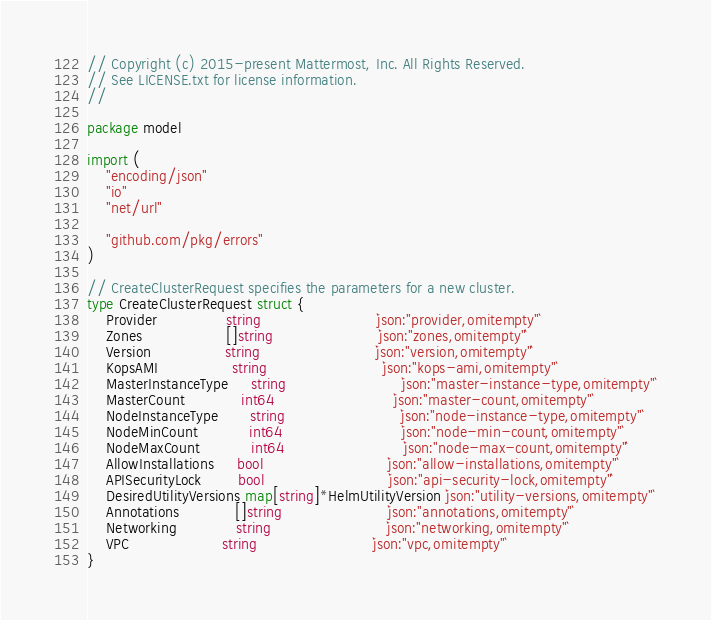Convert code to text. <code><loc_0><loc_0><loc_500><loc_500><_Go_>// Copyright (c) 2015-present Mattermost, Inc. All Rights Reserved.
// See LICENSE.txt for license information.
//

package model

import (
	"encoding/json"
	"io"
	"net/url"

	"github.com/pkg/errors"
)

// CreateClusterRequest specifies the parameters for a new cluster.
type CreateClusterRequest struct {
	Provider               string                         `json:"provider,omitempty"`
	Zones                  []string                       `json:"zones,omitempty"`
	Version                string                         `json:"version,omitempty"`
	KopsAMI                string                         `json:"kops-ami,omitempty"`
	MasterInstanceType     string                         `json:"master-instance-type,omitempty"`
	MasterCount            int64                          `json:"master-count,omitempty"`
	NodeInstanceType       string                         `json:"node-instance-type,omitempty"`
	NodeMinCount           int64                          `json:"node-min-count,omitempty"`
	NodeMaxCount           int64                          `json:"node-max-count,omitempty"`
	AllowInstallations     bool                           `json:"allow-installations,omitempty"`
	APISecurityLock        bool                           `json:"api-security-lock,omitempty"`
	DesiredUtilityVersions map[string]*HelmUtilityVersion `json:"utility-versions,omitempty"`
	Annotations            []string                       `json:"annotations,omitempty"`
	Networking             string                         `json:"networking,omitempty"`
	VPC                    string                         `json:"vpc,omitempty"`
}
</code> 